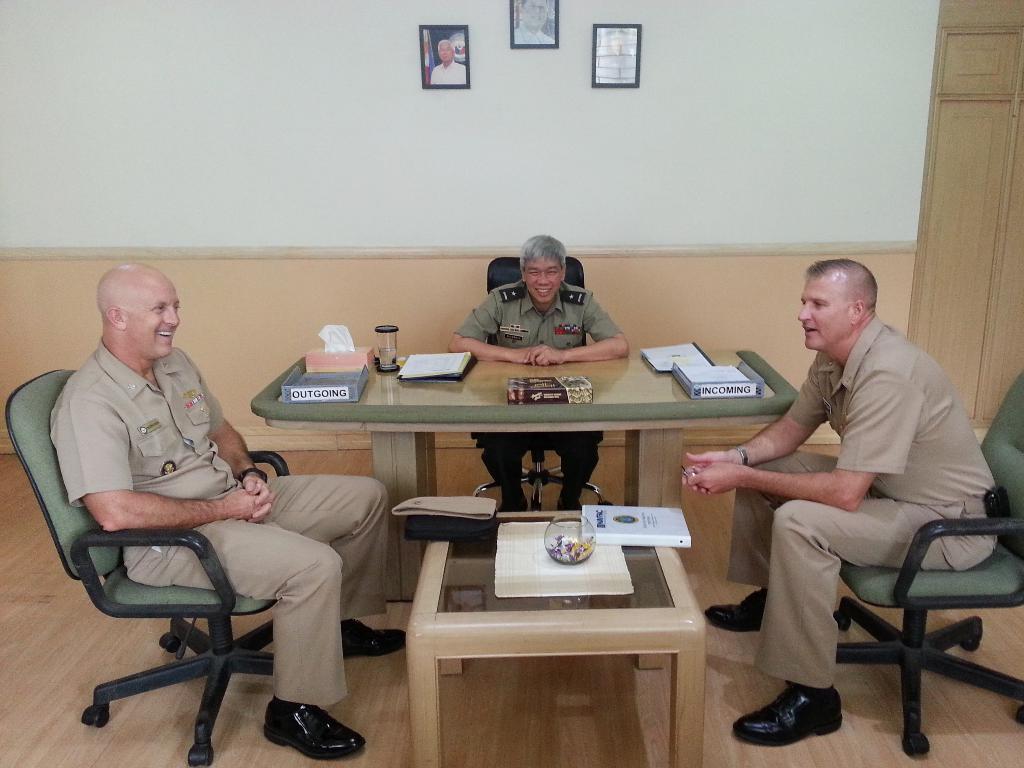In one or two sentences, can you explain what this image depicts? in a room there is a table on which there is a glass pot and a book. left and right to it there are chairs on which 2 people are sitting who are wearing a police uniform. behind them there is a table on which there are books and a outgoing and incoming names boxes are present. behind that a person is sitting on a chair. behind that there is a white wall on which there are 3 photo frames. 